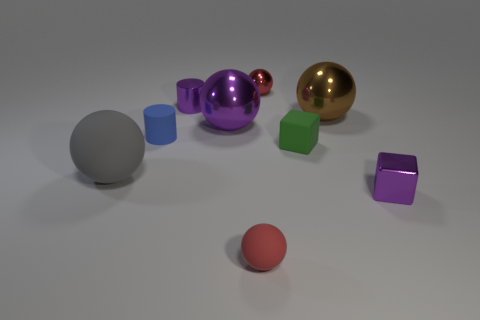Which objects in the image are reflective? The sphere and the tiny cube are reflective, each showing a clear shiny surface that mirrors the environment. And what can you tell me about the colors of the objects? There are multiple colors present: the sphere is purple, the smaller shiny sphere is red, the reflective cube is green, and the matte objects include a gray sphere, a gold sphere, two blue cylinders, and a small purple cube. 